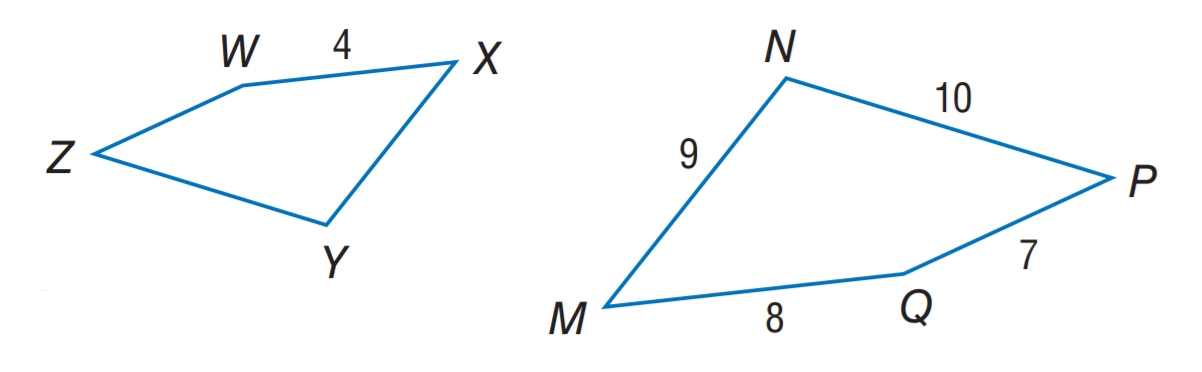Answer the mathemtical geometry problem and directly provide the correct option letter.
Question: If M N P Q \sim X Y Z W, find the perimeter of X Y Z W.
Choices: A: 17 B: 18 C: 20 D: 34 A 